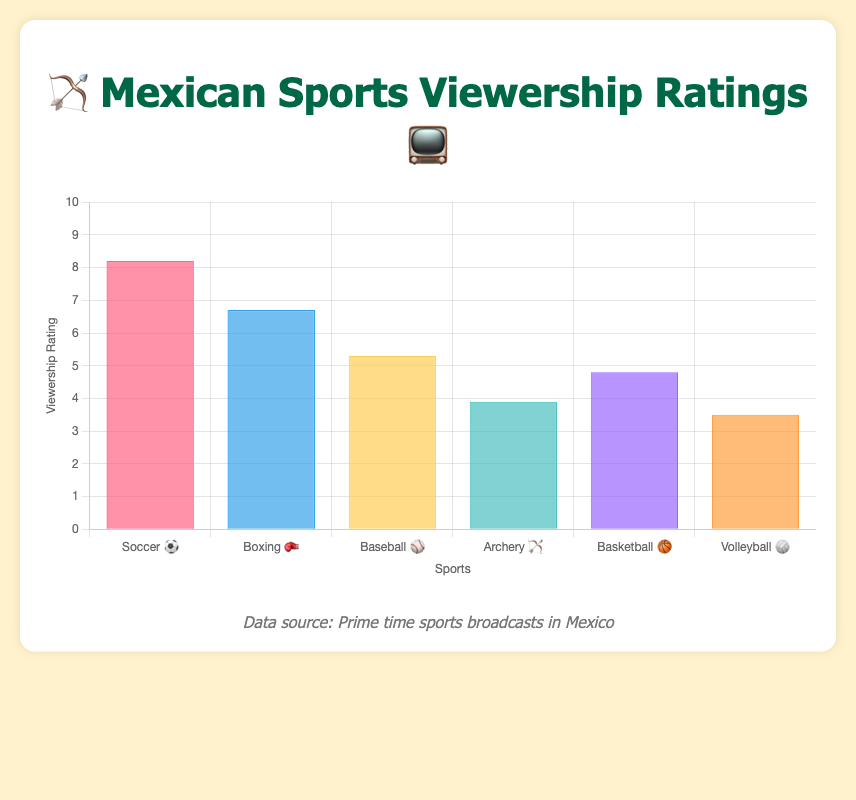Which sport has the highest viewership rating? The highest bar on the chart corresponds to Soccer ⚽ with a viewership rating of 8.2.
Answer: Soccer ⚽ Which sport is broadcasted on Claro Sports? According to the tooltip information, Claro Sports is the network for Archery 🏹.
Answer: Archery 🏹 What is the difference in viewership ratings between Soccer ⚽ and Volleyball 🏐? Soccer ⚽ has a rating of 8.2, and Volleyball 🏐 has a rating of 3.5. The difference is 8.2 - 3.5.
Answer: 4.7 How many sports have viewership ratings above 5.0? The bars for Soccer ⚽, Boxing 🥊, and Baseball ⚾ have ratings above 5.0.
Answer: 3 Which sport has the lowest viewership rating and what is that rating? The shortest bar on the chart corresponds to Volleyball 🏐 with a rating of 3.5.
Answer: Volleyball 🏐, 3.5 What is the average viewership rating of all listed sports? The sum of the ratings is 8.2 + 6.7 + 5.3 + 3.9 + 4.8 + 3.5 = 32.4. There are 6 sports, so the average is 32.4 / 6.
Answer: 5.4 Are there more sports with viewership ratings above or below 5? Soccer ⚽, Boxing 🥊, and Baseball ⚾ are above 5. Archery 🏹, Basketball 🏀, and Volleyball 🏐 are below 5. There are three sports in each category.
Answer: Equal Which sport broadcast on TUDN has a viewership rating close to 5? According to the tooltip information, Basketball 🏀 is the sport on TUDN with a rating of 4.8.
Answer: Basketball 🏀 What is the combined viewership rating for all sports broadcasted on Televisa and TV Azteca? Televisa broadcasts Soccer ⚽ with a rating of 8.2, and TV Azteca broadcasts Boxing 🥊 with a rating of 6.7. The combined rating is 8.2 + 6.7.
Answer: 14.9 